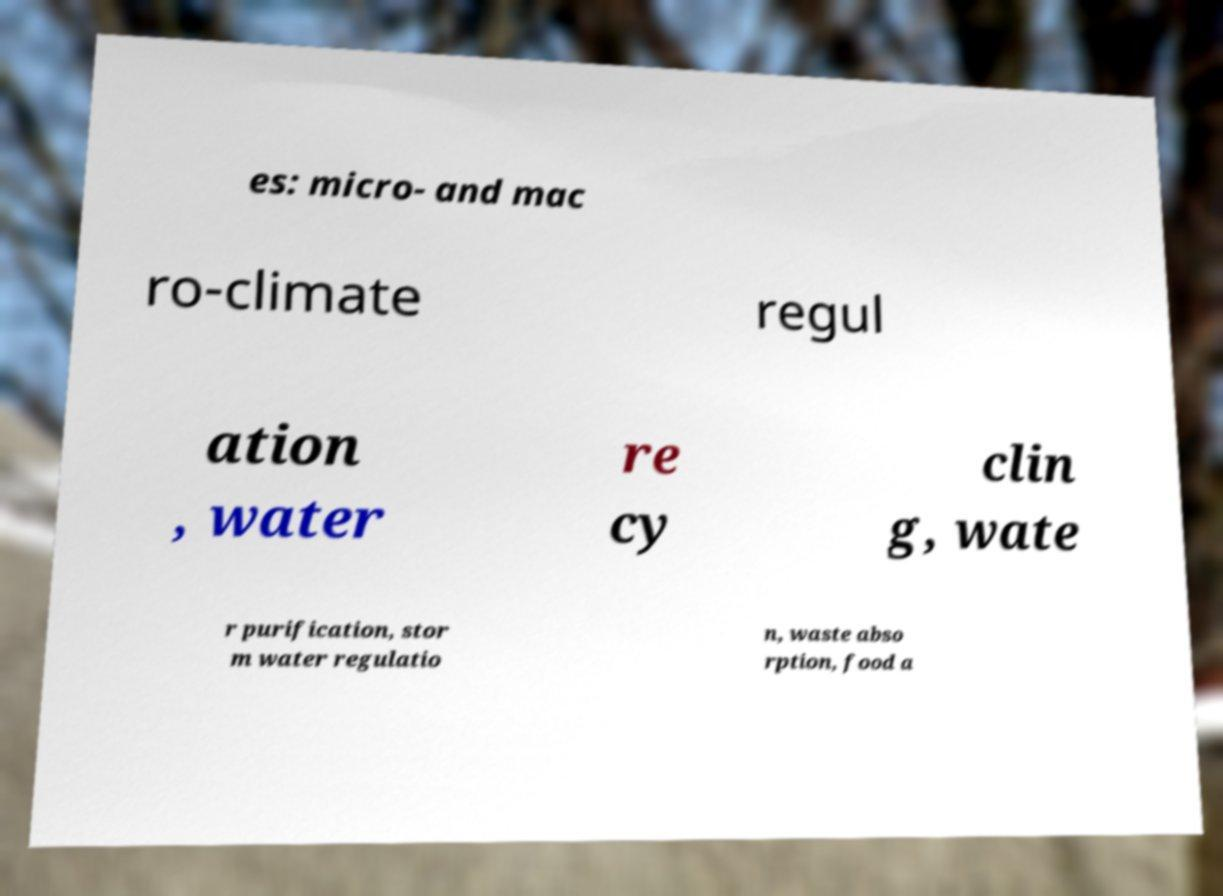Can you read and provide the text displayed in the image?This photo seems to have some interesting text. Can you extract and type it out for me? es: micro- and mac ro-climate regul ation , water re cy clin g, wate r purification, stor m water regulatio n, waste abso rption, food a 